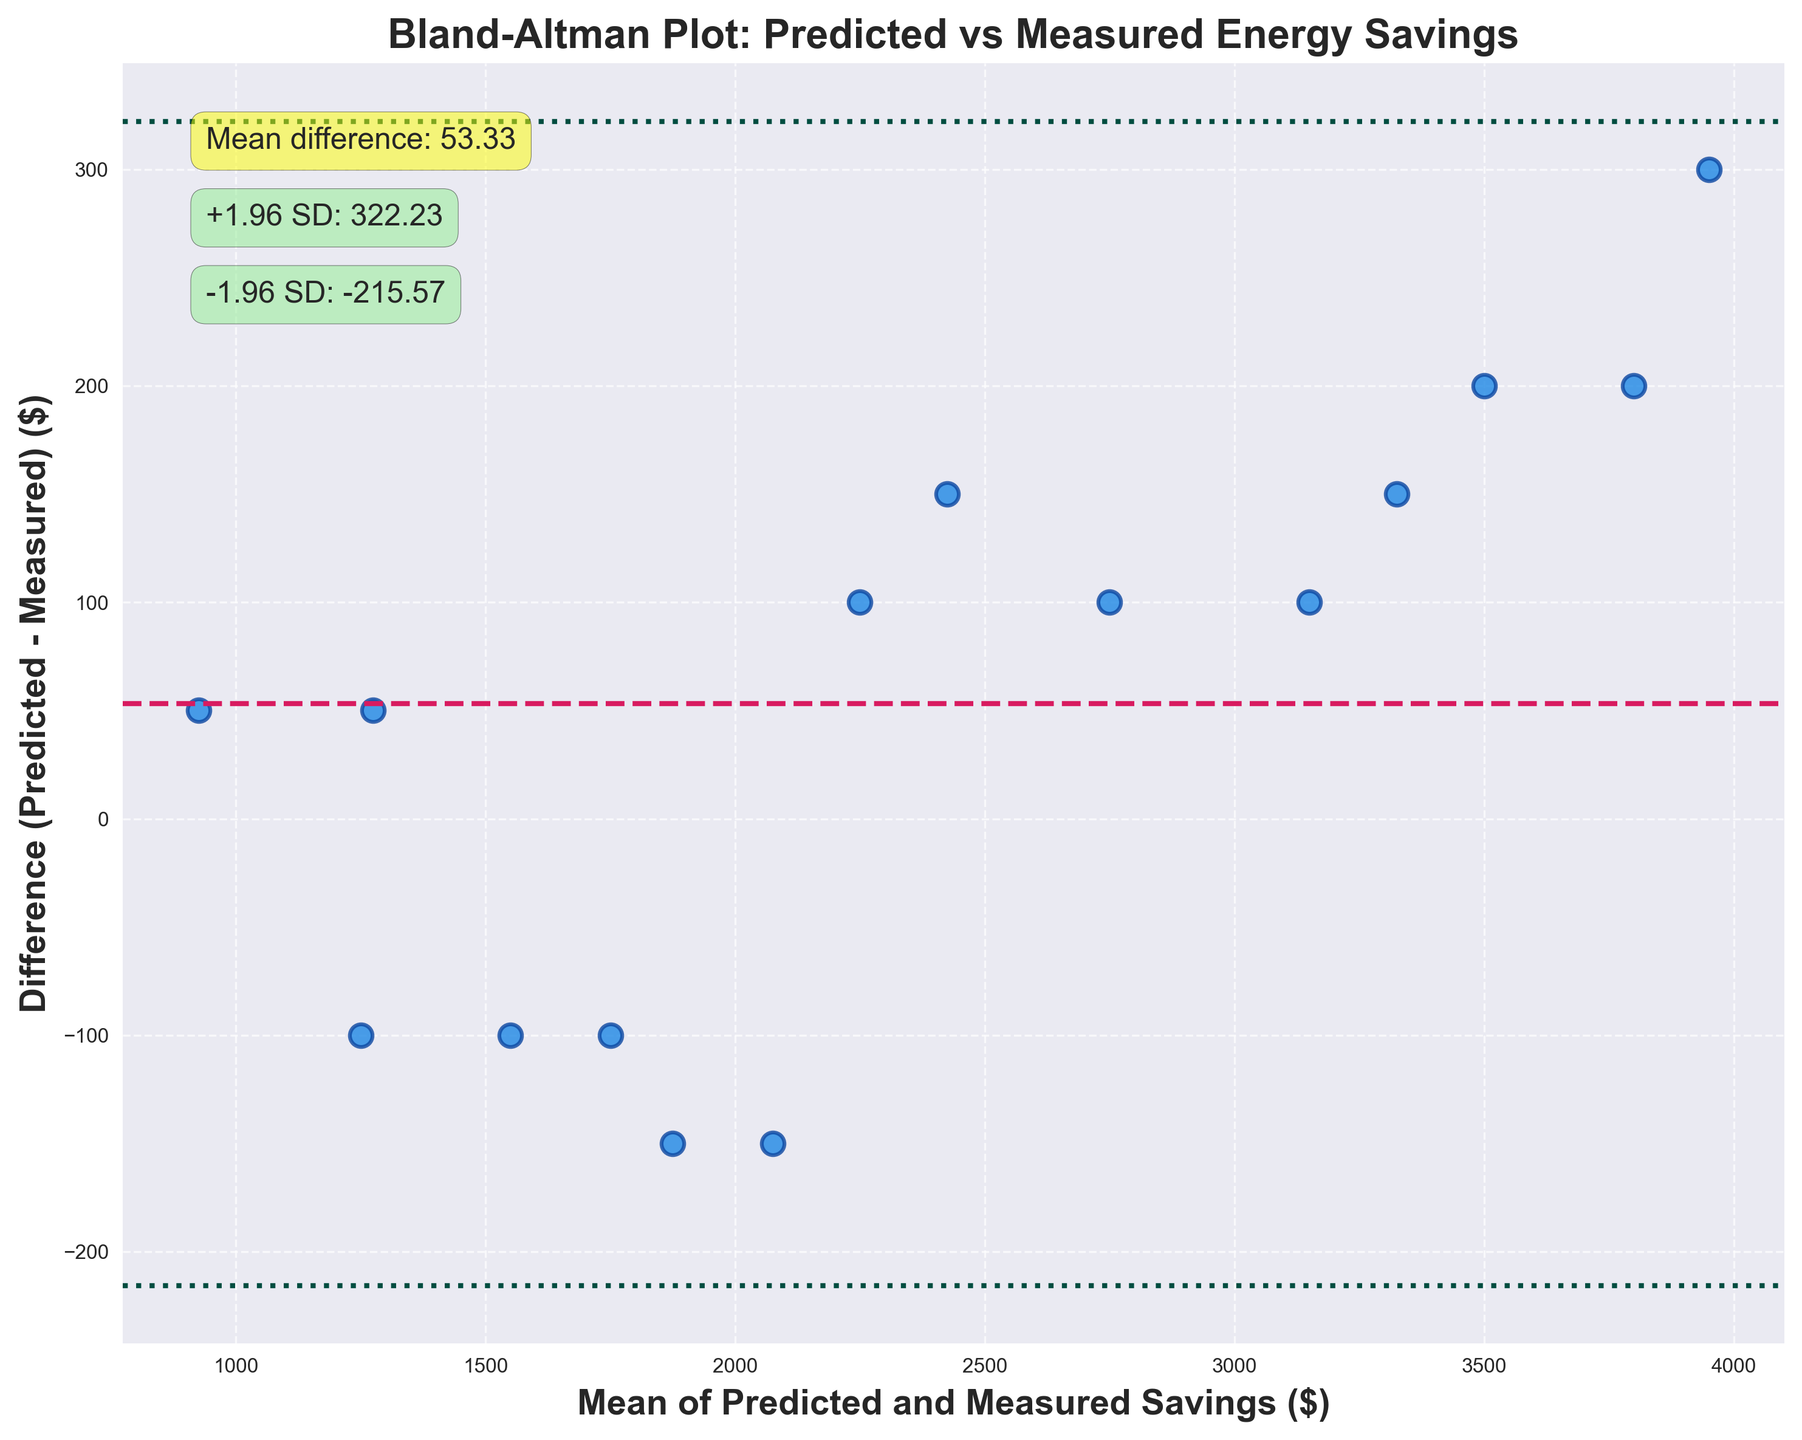How many data points are displayed in the Bland-Altman plot? Count the number of scatter points in the plot.
Answer: 15 What is the title of the figure? Read the text at the top of the figure.
Answer: Bland-Altman Plot: Predicted vs Measured Energy Savings What color are the scatter points in the plot? Observe the color of the points in the figure.
Answer: Blue What is the mean difference between predicted and measured energy savings? Locate the text annotation for "Mean difference" within the plot.
Answer: 48.33 What are the limits of agreement (mean ± 1.96 SD) displayed in the figure? Read the values from the text annotations and horizontal lines representing +1.96 SD and -1.96 SD.
Answer: 257.85 and -161.19 What's the range of the differences in the Bland-Altman plot? Find the difference between the maximum and minimum values on the y-axis.
Answer: 350 Are most of the differences between predicted and measured savings positive or negative? Observe the distribution of points relative to the zero line on the y-axis.
Answer: Positive Which data point has the maximum positive difference between predicted and measured savings? Find the highest point above the zero line on the y-axis and note its coordinates.
Answer: (1000, 300) How many points fall outside the limits of agreement? Count the number of scatter points that lie above +1.96 SD or below -1.96 SD.
Answer: 1 Do the predicted savings generally overestimate or underestimate the measured savings? Determine if more scatter points are above or below the zero line.
Answer: Overestimate 